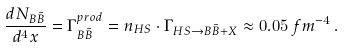Convert formula to latex. <formula><loc_0><loc_0><loc_500><loc_500>\frac { d N _ { B \bar { B } } } { d ^ { 4 } x } = \Gamma ^ { p r o d } _ { B \bar { B } } = n _ { H S } \cdot \Gamma _ { H S \rightarrow B \bar { B } + X } \approx 0 . 0 5 \, f m ^ { - 4 } \, .</formula> 